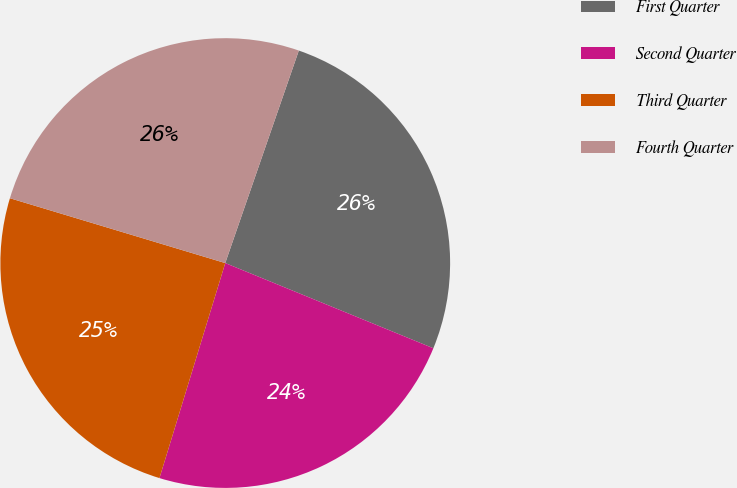<chart> <loc_0><loc_0><loc_500><loc_500><pie_chart><fcel>First Quarter<fcel>Second Quarter<fcel>Third Quarter<fcel>Fourth Quarter<nl><fcel>25.88%<fcel>23.54%<fcel>24.93%<fcel>25.65%<nl></chart> 